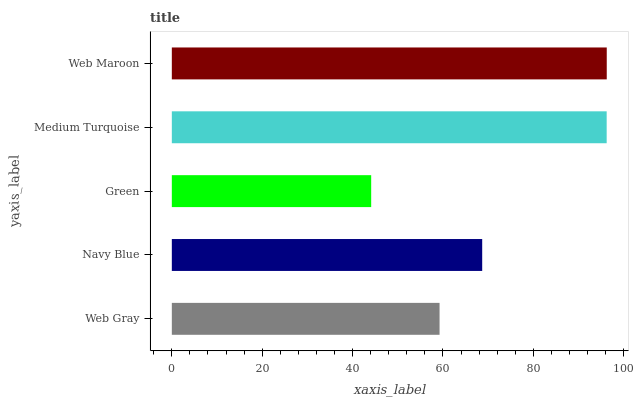Is Green the minimum?
Answer yes or no. Yes. Is Web Maroon the maximum?
Answer yes or no. Yes. Is Navy Blue the minimum?
Answer yes or no. No. Is Navy Blue the maximum?
Answer yes or no. No. Is Navy Blue greater than Web Gray?
Answer yes or no. Yes. Is Web Gray less than Navy Blue?
Answer yes or no. Yes. Is Web Gray greater than Navy Blue?
Answer yes or no. No. Is Navy Blue less than Web Gray?
Answer yes or no. No. Is Navy Blue the high median?
Answer yes or no. Yes. Is Navy Blue the low median?
Answer yes or no. Yes. Is Medium Turquoise the high median?
Answer yes or no. No. Is Web Gray the low median?
Answer yes or no. No. 